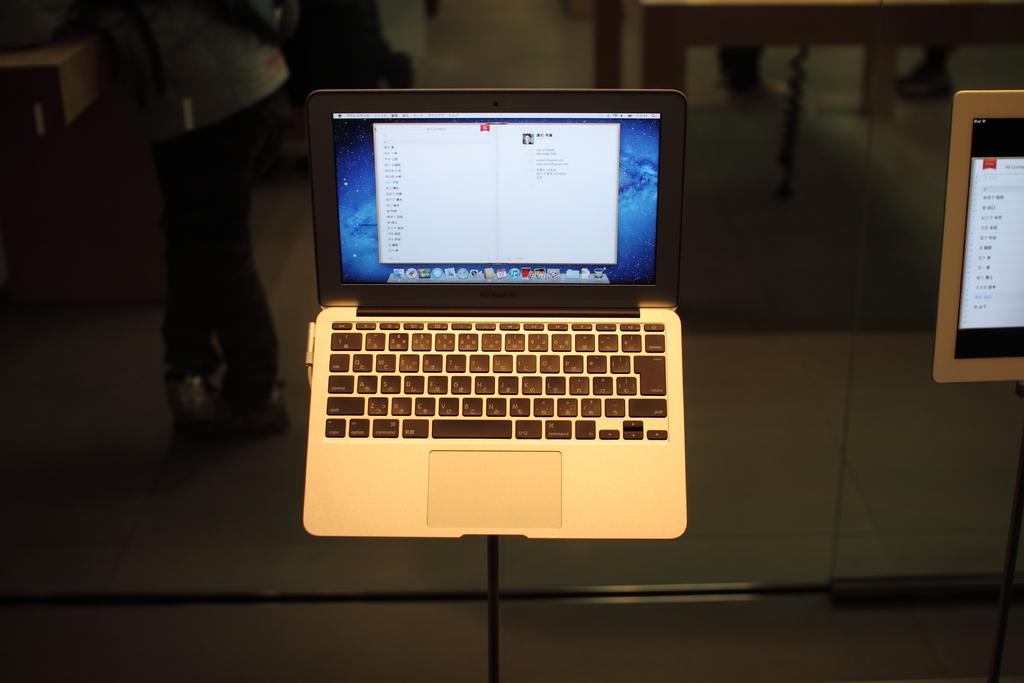What electronic device is present in the image? There is a laptop in the image. Can you describe anything else visible in the image? There is a human leg visible in the background of the image. What is the taste of the laptop in the image? The laptop does not have a taste, as it is an electronic device and not a food item. 